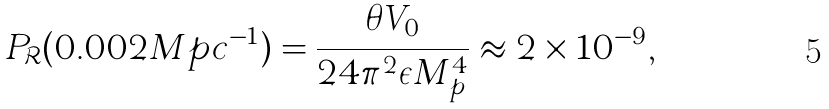<formula> <loc_0><loc_0><loc_500><loc_500>P _ { \mathcal { R } } ( 0 . 0 0 2 M p c ^ { - 1 } ) = \frac { \theta V _ { 0 } } { 2 4 \pi ^ { 2 } \epsilon M _ { p } ^ { 4 } } \approx 2 \times 1 0 ^ { - 9 } ,</formula> 